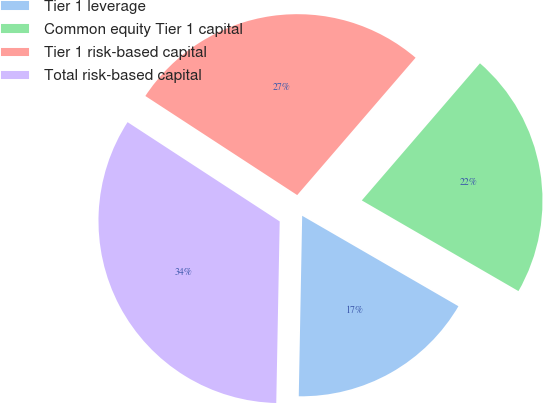Convert chart to OTSL. <chart><loc_0><loc_0><loc_500><loc_500><pie_chart><fcel>Tier 1 leverage<fcel>Common equity Tier 1 capital<fcel>Tier 1 risk-based capital<fcel>Total risk-based capital<nl><fcel>16.95%<fcel>22.03%<fcel>27.12%<fcel>33.9%<nl></chart> 